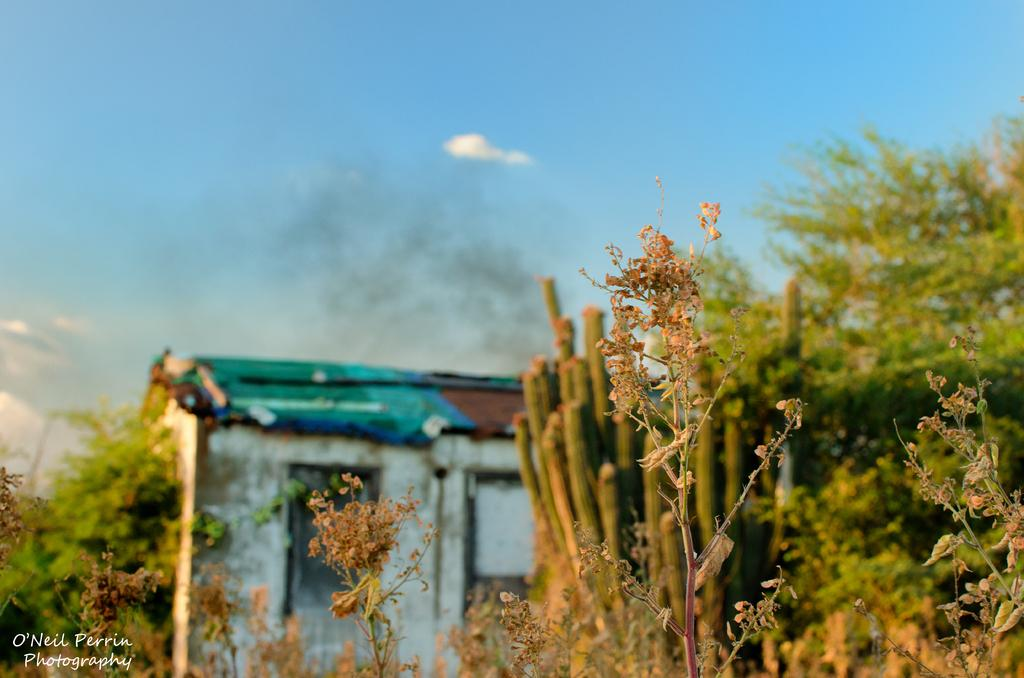What type of vegetation can be seen in the image? There are plants and trees in the image. What type of structure is depicted in the image? The image appears to depict a house. What is visible in the sky in the image? Clouds are visible in the sky. What type of juice is being served in the prison depicted in the image? There is no prison or juice present in the image; it features plants, trees, and a house. What color is the nose of the person standing in front of the house in the image? There is no person or nose present in the image; it only features plants, trees, and a house. 